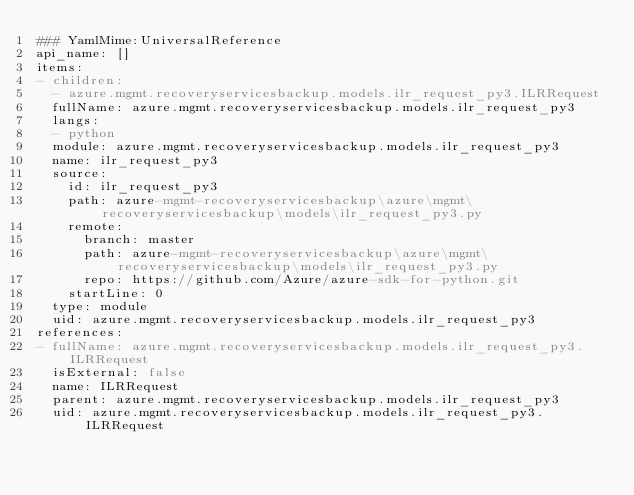<code> <loc_0><loc_0><loc_500><loc_500><_YAML_>### YamlMime:UniversalReference
api_name: []
items:
- children:
  - azure.mgmt.recoveryservicesbackup.models.ilr_request_py3.ILRRequest
  fullName: azure.mgmt.recoveryservicesbackup.models.ilr_request_py3
  langs:
  - python
  module: azure.mgmt.recoveryservicesbackup.models.ilr_request_py3
  name: ilr_request_py3
  source:
    id: ilr_request_py3
    path: azure-mgmt-recoveryservicesbackup\azure\mgmt\recoveryservicesbackup\models\ilr_request_py3.py
    remote:
      branch: master
      path: azure-mgmt-recoveryservicesbackup\azure\mgmt\recoveryservicesbackup\models\ilr_request_py3.py
      repo: https://github.com/Azure/azure-sdk-for-python.git
    startLine: 0
  type: module
  uid: azure.mgmt.recoveryservicesbackup.models.ilr_request_py3
references:
- fullName: azure.mgmt.recoveryservicesbackup.models.ilr_request_py3.ILRRequest
  isExternal: false
  name: ILRRequest
  parent: azure.mgmt.recoveryservicesbackup.models.ilr_request_py3
  uid: azure.mgmt.recoveryservicesbackup.models.ilr_request_py3.ILRRequest
</code> 